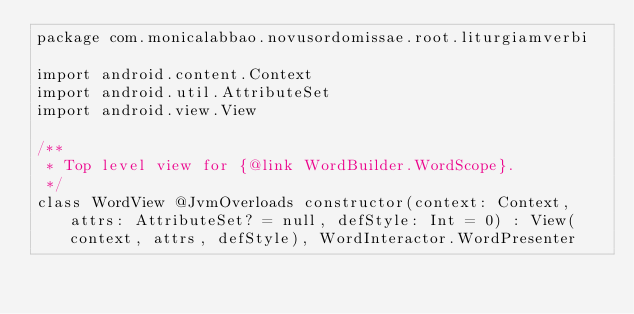Convert code to text. <code><loc_0><loc_0><loc_500><loc_500><_Kotlin_>package com.monicalabbao.novusordomissae.root.liturgiamverbi

import android.content.Context
import android.util.AttributeSet
import android.view.View

/**
 * Top level view for {@link WordBuilder.WordScope}.
 */
class WordView @JvmOverloads constructor(context: Context, attrs: AttributeSet? = null, defStyle: Int = 0) : View(context, attrs, defStyle), WordInteractor.WordPresenter
</code> 